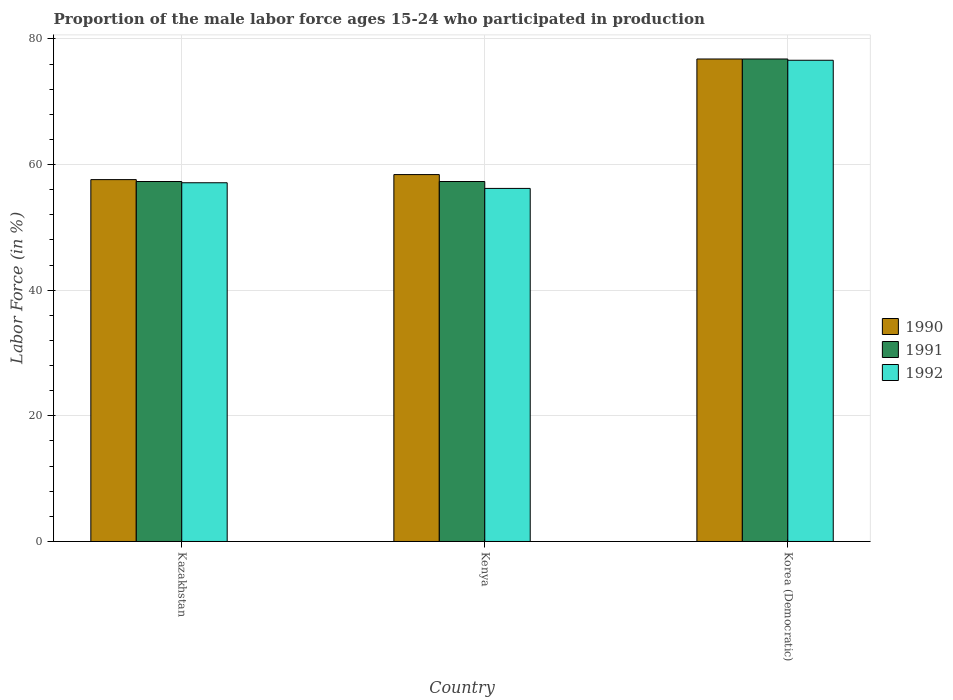How many different coloured bars are there?
Your response must be concise. 3. How many groups of bars are there?
Keep it short and to the point. 3. How many bars are there on the 1st tick from the right?
Your response must be concise. 3. What is the label of the 1st group of bars from the left?
Give a very brief answer. Kazakhstan. What is the proportion of the male labor force who participated in production in 1991 in Kenya?
Give a very brief answer. 57.3. Across all countries, what is the maximum proportion of the male labor force who participated in production in 1992?
Provide a short and direct response. 76.6. Across all countries, what is the minimum proportion of the male labor force who participated in production in 1990?
Your response must be concise. 57.6. In which country was the proportion of the male labor force who participated in production in 1992 maximum?
Your answer should be very brief. Korea (Democratic). In which country was the proportion of the male labor force who participated in production in 1990 minimum?
Your answer should be very brief. Kazakhstan. What is the total proportion of the male labor force who participated in production in 1991 in the graph?
Offer a terse response. 191.4. What is the difference between the proportion of the male labor force who participated in production in 1991 in Kenya and that in Korea (Democratic)?
Keep it short and to the point. -19.5. What is the difference between the proportion of the male labor force who participated in production in 1991 in Korea (Democratic) and the proportion of the male labor force who participated in production in 1990 in Kazakhstan?
Provide a succinct answer. 19.2. What is the average proportion of the male labor force who participated in production in 1992 per country?
Ensure brevity in your answer.  63.3. What is the difference between the proportion of the male labor force who participated in production of/in 1990 and proportion of the male labor force who participated in production of/in 1991 in Kazakhstan?
Ensure brevity in your answer.  0.3. In how many countries, is the proportion of the male labor force who participated in production in 1991 greater than 4 %?
Keep it short and to the point. 3. What is the ratio of the proportion of the male labor force who participated in production in 1990 in Kenya to that in Korea (Democratic)?
Your answer should be compact. 0.76. What is the difference between the highest and the second highest proportion of the male labor force who participated in production in 1990?
Your answer should be compact. -0.8. What is the difference between the highest and the lowest proportion of the male labor force who participated in production in 1991?
Provide a short and direct response. 19.5. Is the sum of the proportion of the male labor force who participated in production in 1992 in Kazakhstan and Kenya greater than the maximum proportion of the male labor force who participated in production in 1991 across all countries?
Ensure brevity in your answer.  Yes. What does the 3rd bar from the left in Kazakhstan represents?
Your answer should be very brief. 1992. What does the 3rd bar from the right in Kenya represents?
Give a very brief answer. 1990. Is it the case that in every country, the sum of the proportion of the male labor force who participated in production in 1992 and proportion of the male labor force who participated in production in 1991 is greater than the proportion of the male labor force who participated in production in 1990?
Keep it short and to the point. Yes. Are all the bars in the graph horizontal?
Make the answer very short. No. How many countries are there in the graph?
Offer a very short reply. 3. Does the graph contain any zero values?
Keep it short and to the point. No. How many legend labels are there?
Offer a terse response. 3. What is the title of the graph?
Your answer should be compact. Proportion of the male labor force ages 15-24 who participated in production. Does "1966" appear as one of the legend labels in the graph?
Keep it short and to the point. No. What is the label or title of the Y-axis?
Ensure brevity in your answer.  Labor Force (in %). What is the Labor Force (in %) of 1990 in Kazakhstan?
Give a very brief answer. 57.6. What is the Labor Force (in %) in 1991 in Kazakhstan?
Offer a very short reply. 57.3. What is the Labor Force (in %) of 1992 in Kazakhstan?
Ensure brevity in your answer.  57.1. What is the Labor Force (in %) of 1990 in Kenya?
Give a very brief answer. 58.4. What is the Labor Force (in %) in 1991 in Kenya?
Provide a succinct answer. 57.3. What is the Labor Force (in %) in 1992 in Kenya?
Give a very brief answer. 56.2. What is the Labor Force (in %) of 1990 in Korea (Democratic)?
Keep it short and to the point. 76.8. What is the Labor Force (in %) in 1991 in Korea (Democratic)?
Make the answer very short. 76.8. What is the Labor Force (in %) in 1992 in Korea (Democratic)?
Offer a very short reply. 76.6. Across all countries, what is the maximum Labor Force (in %) of 1990?
Provide a short and direct response. 76.8. Across all countries, what is the maximum Labor Force (in %) of 1991?
Keep it short and to the point. 76.8. Across all countries, what is the maximum Labor Force (in %) in 1992?
Ensure brevity in your answer.  76.6. Across all countries, what is the minimum Labor Force (in %) of 1990?
Make the answer very short. 57.6. Across all countries, what is the minimum Labor Force (in %) of 1991?
Give a very brief answer. 57.3. Across all countries, what is the minimum Labor Force (in %) in 1992?
Make the answer very short. 56.2. What is the total Labor Force (in %) in 1990 in the graph?
Your answer should be compact. 192.8. What is the total Labor Force (in %) of 1991 in the graph?
Your answer should be very brief. 191.4. What is the total Labor Force (in %) in 1992 in the graph?
Offer a very short reply. 189.9. What is the difference between the Labor Force (in %) in 1992 in Kazakhstan and that in Kenya?
Provide a short and direct response. 0.9. What is the difference between the Labor Force (in %) in 1990 in Kazakhstan and that in Korea (Democratic)?
Provide a short and direct response. -19.2. What is the difference between the Labor Force (in %) of 1991 in Kazakhstan and that in Korea (Democratic)?
Make the answer very short. -19.5. What is the difference between the Labor Force (in %) in 1992 in Kazakhstan and that in Korea (Democratic)?
Ensure brevity in your answer.  -19.5. What is the difference between the Labor Force (in %) in 1990 in Kenya and that in Korea (Democratic)?
Ensure brevity in your answer.  -18.4. What is the difference between the Labor Force (in %) of 1991 in Kenya and that in Korea (Democratic)?
Offer a terse response. -19.5. What is the difference between the Labor Force (in %) in 1992 in Kenya and that in Korea (Democratic)?
Your answer should be compact. -20.4. What is the difference between the Labor Force (in %) of 1990 in Kazakhstan and the Labor Force (in %) of 1991 in Kenya?
Your answer should be very brief. 0.3. What is the difference between the Labor Force (in %) of 1990 in Kazakhstan and the Labor Force (in %) of 1992 in Kenya?
Your answer should be compact. 1.4. What is the difference between the Labor Force (in %) in 1990 in Kazakhstan and the Labor Force (in %) in 1991 in Korea (Democratic)?
Your response must be concise. -19.2. What is the difference between the Labor Force (in %) of 1990 in Kazakhstan and the Labor Force (in %) of 1992 in Korea (Democratic)?
Provide a succinct answer. -19. What is the difference between the Labor Force (in %) of 1991 in Kazakhstan and the Labor Force (in %) of 1992 in Korea (Democratic)?
Offer a terse response. -19.3. What is the difference between the Labor Force (in %) of 1990 in Kenya and the Labor Force (in %) of 1991 in Korea (Democratic)?
Offer a terse response. -18.4. What is the difference between the Labor Force (in %) of 1990 in Kenya and the Labor Force (in %) of 1992 in Korea (Democratic)?
Provide a succinct answer. -18.2. What is the difference between the Labor Force (in %) in 1991 in Kenya and the Labor Force (in %) in 1992 in Korea (Democratic)?
Keep it short and to the point. -19.3. What is the average Labor Force (in %) of 1990 per country?
Make the answer very short. 64.27. What is the average Labor Force (in %) of 1991 per country?
Your response must be concise. 63.8. What is the average Labor Force (in %) of 1992 per country?
Keep it short and to the point. 63.3. What is the difference between the Labor Force (in %) in 1990 and Labor Force (in %) in 1991 in Kazakhstan?
Give a very brief answer. 0.3. What is the difference between the Labor Force (in %) of 1990 and Labor Force (in %) of 1992 in Kazakhstan?
Give a very brief answer. 0.5. What is the difference between the Labor Force (in %) of 1991 and Labor Force (in %) of 1992 in Kazakhstan?
Offer a very short reply. 0.2. What is the difference between the Labor Force (in %) in 1990 and Labor Force (in %) in 1992 in Kenya?
Your answer should be compact. 2.2. What is the difference between the Labor Force (in %) in 1991 and Labor Force (in %) in 1992 in Kenya?
Provide a short and direct response. 1.1. What is the difference between the Labor Force (in %) in 1990 and Labor Force (in %) in 1992 in Korea (Democratic)?
Your answer should be very brief. 0.2. What is the difference between the Labor Force (in %) in 1991 and Labor Force (in %) in 1992 in Korea (Democratic)?
Make the answer very short. 0.2. What is the ratio of the Labor Force (in %) of 1990 in Kazakhstan to that in Kenya?
Offer a very short reply. 0.99. What is the ratio of the Labor Force (in %) of 1992 in Kazakhstan to that in Kenya?
Ensure brevity in your answer.  1.02. What is the ratio of the Labor Force (in %) of 1990 in Kazakhstan to that in Korea (Democratic)?
Provide a short and direct response. 0.75. What is the ratio of the Labor Force (in %) in 1991 in Kazakhstan to that in Korea (Democratic)?
Ensure brevity in your answer.  0.75. What is the ratio of the Labor Force (in %) in 1992 in Kazakhstan to that in Korea (Democratic)?
Provide a short and direct response. 0.75. What is the ratio of the Labor Force (in %) of 1990 in Kenya to that in Korea (Democratic)?
Make the answer very short. 0.76. What is the ratio of the Labor Force (in %) of 1991 in Kenya to that in Korea (Democratic)?
Keep it short and to the point. 0.75. What is the ratio of the Labor Force (in %) in 1992 in Kenya to that in Korea (Democratic)?
Offer a terse response. 0.73. What is the difference between the highest and the second highest Labor Force (in %) of 1991?
Keep it short and to the point. 19.5. What is the difference between the highest and the second highest Labor Force (in %) in 1992?
Provide a short and direct response. 19.5. What is the difference between the highest and the lowest Labor Force (in %) in 1991?
Make the answer very short. 19.5. What is the difference between the highest and the lowest Labor Force (in %) of 1992?
Make the answer very short. 20.4. 